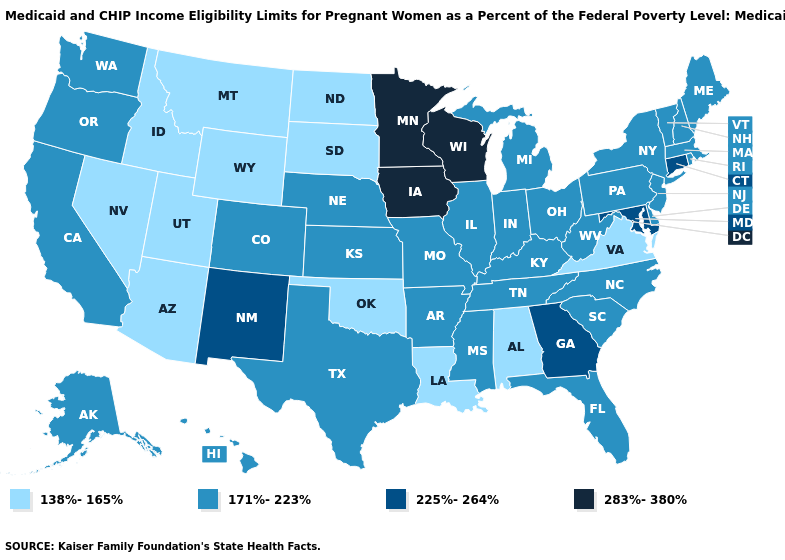What is the highest value in the USA?
Quick response, please. 283%-380%. What is the value of Virginia?
Answer briefly. 138%-165%. Among the states that border Georgia , does Florida have the highest value?
Give a very brief answer. Yes. Among the states that border Nevada , does Arizona have the highest value?
Write a very short answer. No. Which states have the lowest value in the USA?
Answer briefly. Alabama, Arizona, Idaho, Louisiana, Montana, Nevada, North Dakota, Oklahoma, South Dakota, Utah, Virginia, Wyoming. Is the legend a continuous bar?
Be succinct. No. Name the states that have a value in the range 225%-264%?
Write a very short answer. Connecticut, Georgia, Maryland, New Mexico. Is the legend a continuous bar?
Quick response, please. No. Name the states that have a value in the range 225%-264%?
Write a very short answer. Connecticut, Georgia, Maryland, New Mexico. Name the states that have a value in the range 225%-264%?
Short answer required. Connecticut, Georgia, Maryland, New Mexico. Among the states that border Colorado , does Arizona have the lowest value?
Give a very brief answer. Yes. Name the states that have a value in the range 171%-223%?
Write a very short answer. Alaska, Arkansas, California, Colorado, Delaware, Florida, Hawaii, Illinois, Indiana, Kansas, Kentucky, Maine, Massachusetts, Michigan, Mississippi, Missouri, Nebraska, New Hampshire, New Jersey, New York, North Carolina, Ohio, Oregon, Pennsylvania, Rhode Island, South Carolina, Tennessee, Texas, Vermont, Washington, West Virginia. Does Nevada have the same value as Iowa?
Keep it brief. No. What is the lowest value in the USA?
Keep it brief. 138%-165%. 